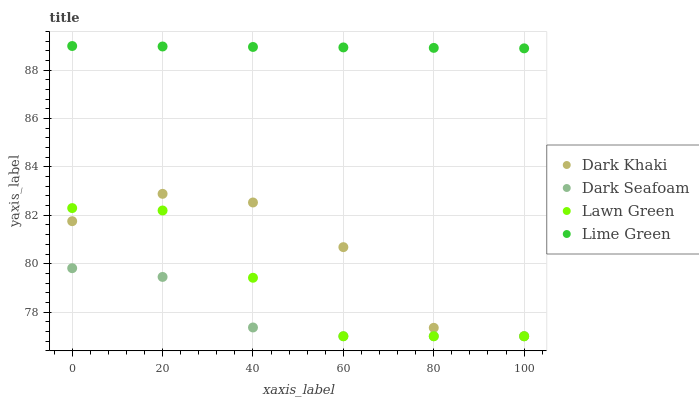Does Dark Seafoam have the minimum area under the curve?
Answer yes or no. Yes. Does Lime Green have the maximum area under the curve?
Answer yes or no. Yes. Does Lawn Green have the minimum area under the curve?
Answer yes or no. No. Does Lawn Green have the maximum area under the curve?
Answer yes or no. No. Is Lime Green the smoothest?
Answer yes or no. Yes. Is Dark Khaki the roughest?
Answer yes or no. Yes. Is Lawn Green the smoothest?
Answer yes or no. No. Is Lawn Green the roughest?
Answer yes or no. No. Does Dark Khaki have the lowest value?
Answer yes or no. Yes. Does Lime Green have the lowest value?
Answer yes or no. No. Does Lime Green have the highest value?
Answer yes or no. Yes. Does Lawn Green have the highest value?
Answer yes or no. No. Is Dark Seafoam less than Lime Green?
Answer yes or no. Yes. Is Lime Green greater than Lawn Green?
Answer yes or no. Yes. Does Lawn Green intersect Dark Seafoam?
Answer yes or no. Yes. Is Lawn Green less than Dark Seafoam?
Answer yes or no. No. Is Lawn Green greater than Dark Seafoam?
Answer yes or no. No. Does Dark Seafoam intersect Lime Green?
Answer yes or no. No. 